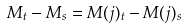Convert formula to latex. <formula><loc_0><loc_0><loc_500><loc_500>M _ { t } - M _ { s } = M ( j ) _ { t } - M ( j ) _ { s }</formula> 